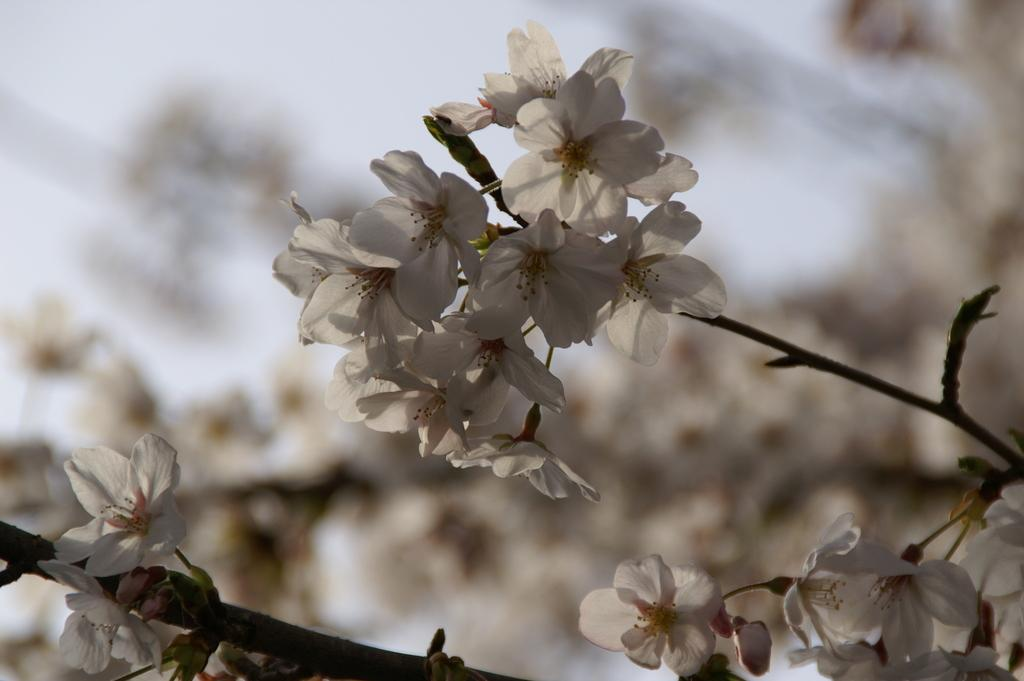What type of flowers are in the image? There are white color flowers in the image. What can be seen connected to the flowers? There are stems in the image. Can you describe the background of the image? The background of the image is blurry. What type of leather is used to make the basket in the image? There is no basket present in the image, so the type of leather cannot be determined. 